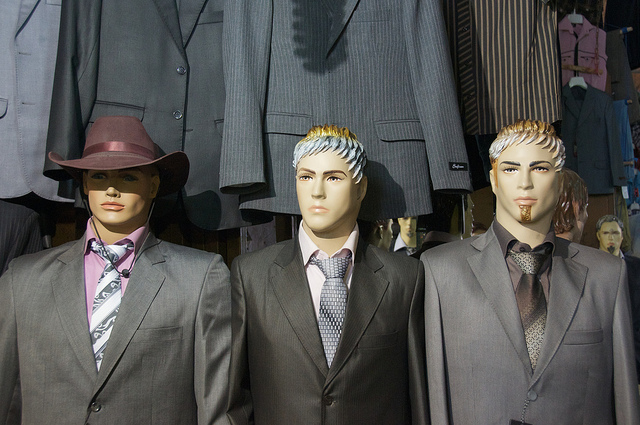<image>Are these living people? No, these are not living people. Are these living people? I don't know if these people are living or not. We can't determine their status based on the given information. 